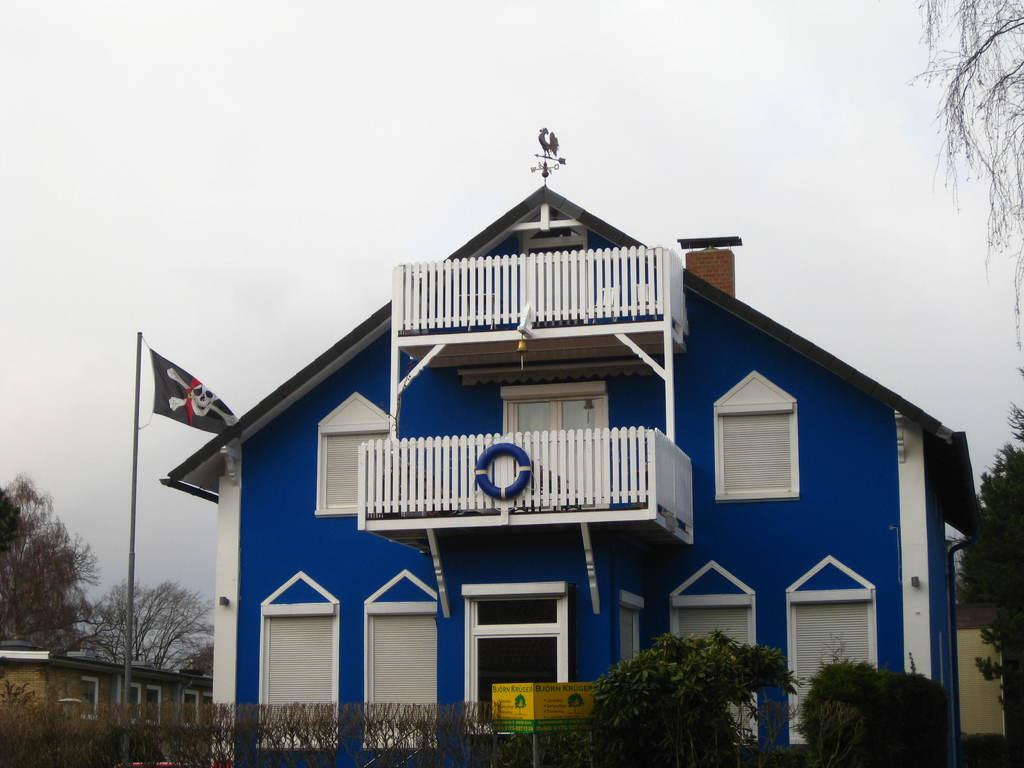What type of structures can be seen in the image? There are buildings in the image. What natural elements are present in the image? There are trees and plants visible in the image. What architectural feature can be seen in the image? Railings are present in the image. What symbol or emblem is visible in the image? There is a flag in the image. What object can be used for displaying information or advertisements? There is a board in the image. What is visible at the top of the image? The sky is visible at the top of the image. How many cats are sitting on the board in the image? There are no cats present in the image. What type of salt is being used to season the plants in the image? There is no salt or seasoning visible in the image; it only features plants, a board, and other elements mentioned in the facts. 